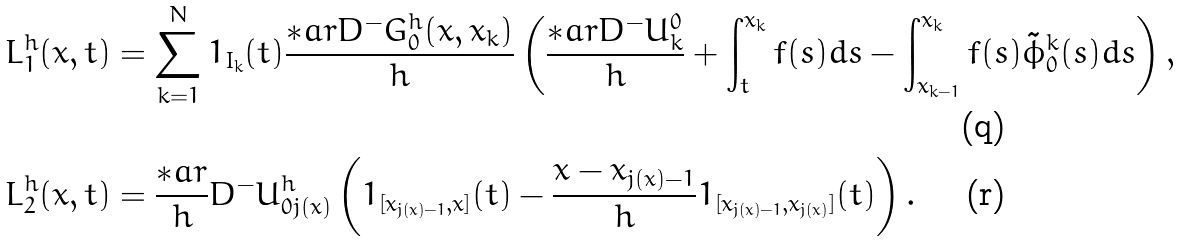<formula> <loc_0><loc_0><loc_500><loc_500>L ^ { h } _ { 1 } ( x , t ) & = \sum _ { k = 1 } ^ { N } { 1 } _ { I _ { k } } ( t ) \frac { \ast a r D ^ { - } G ^ { h } _ { 0 } ( x , x _ { k } ) } { h } \left ( \frac { \ast a r D ^ { - } U ^ { 0 } _ { k } } { h } + \int _ { t } ^ { x _ { k } } f ( s ) d s - \int _ { x _ { k - 1 } } ^ { x _ { k } } f ( s ) \tilde { \phi } ^ { k } _ { 0 } ( s ) d s \right ) , \\ L ^ { h } _ { 2 } ( x , t ) & = \frac { \ast a r } { h } D ^ { - } U ^ { h } _ { 0 j ( x ) } \left ( { 1 } _ { [ x _ { j ( x ) - 1 } , x ] } ( t ) - \frac { x - x _ { j ( x ) - 1 } } { h } { 1 } _ { [ x _ { j ( x ) - 1 } , x _ { j ( x ) } ] } ( t ) \right ) .</formula> 